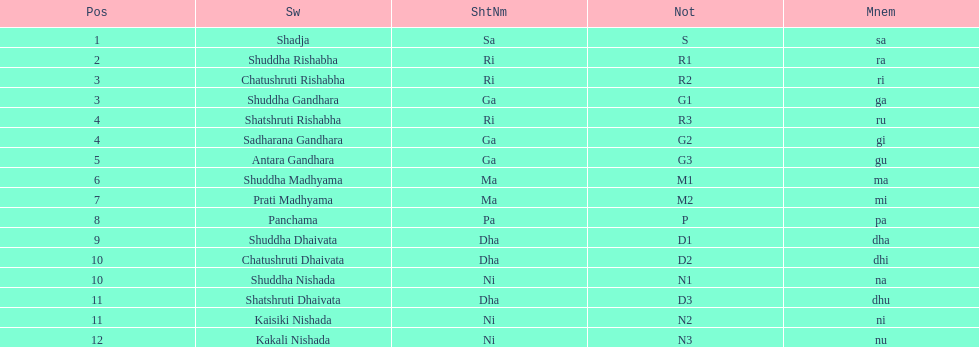On average how many of the swara have a short name that begin with d or g? 6. 